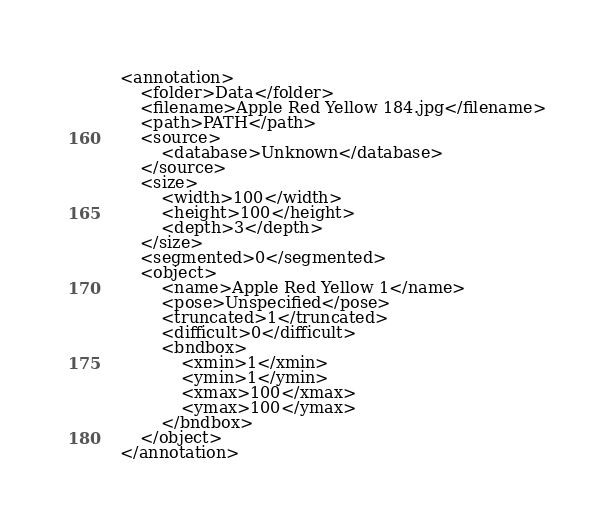Convert code to text. <code><loc_0><loc_0><loc_500><loc_500><_XML_><annotation>
	<folder>Data</folder>
	<filename>Apple Red Yellow 184.jpg</filename>
	<path>PATH</path>
	<source>
		<database>Unknown</database>
	</source>
	<size>
		<width>100</width>
		<height>100</height>
		<depth>3</depth>
	</size>
	<segmented>0</segmented>
	<object>
		<name>Apple Red Yellow 1</name>
		<pose>Unspecified</pose>
		<truncated>1</truncated>
		<difficult>0</difficult>
		<bndbox>
			<xmin>1</xmin>
			<ymin>1</ymin>
			<xmax>100</xmax>
			<ymax>100</ymax>
		</bndbox>
	</object>
</annotation>
</code> 